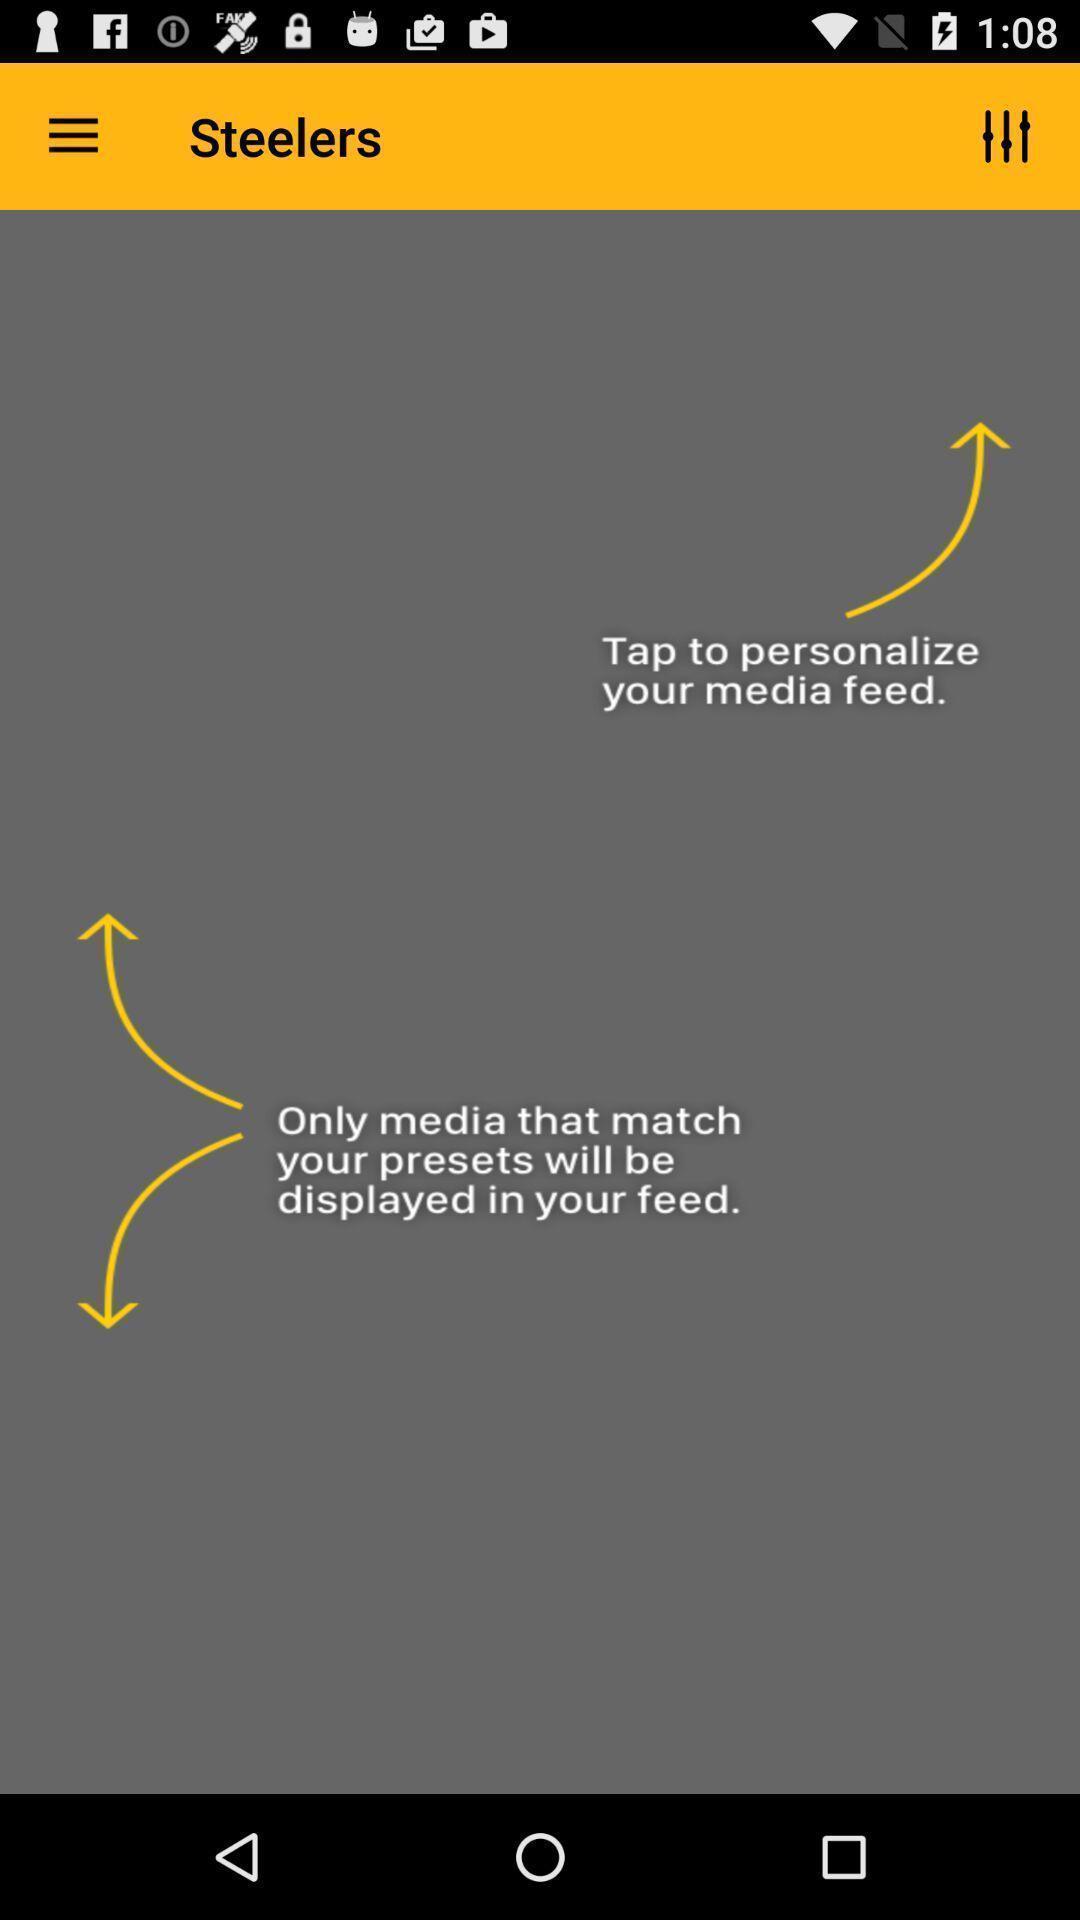Please provide a description for this image. Screen displaying the media feed icon. 